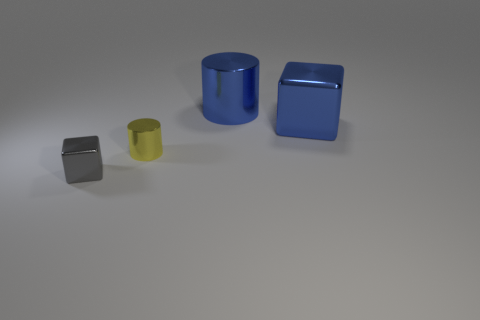What is the shape of the tiny metallic object in front of the shiny cylinder that is in front of the large object behind the blue cube?
Provide a short and direct response. Cube. Is the number of tiny gray metal things left of the yellow object greater than the number of purple metallic blocks?
Offer a very short reply. Yes. Do the gray thing and the small object behind the tiny shiny cube have the same shape?
Your answer should be compact. No. The big shiny thing that is the same color as the big block is what shape?
Keep it short and to the point. Cylinder. How many small yellow metal things are in front of the metal cylinder left of the blue thing behind the big blue shiny cube?
Give a very brief answer. 0. There is another object that is the same size as the yellow metallic thing; what color is it?
Keep it short and to the point. Gray. How big is the cube to the left of the tiny metallic thing that is behind the gray shiny cube?
Make the answer very short. Small. There is a metal cube that is the same color as the big cylinder; what size is it?
Your response must be concise. Large. What number of other things are the same size as the blue block?
Your response must be concise. 1. What number of big blue cylinders are there?
Offer a terse response. 1. 